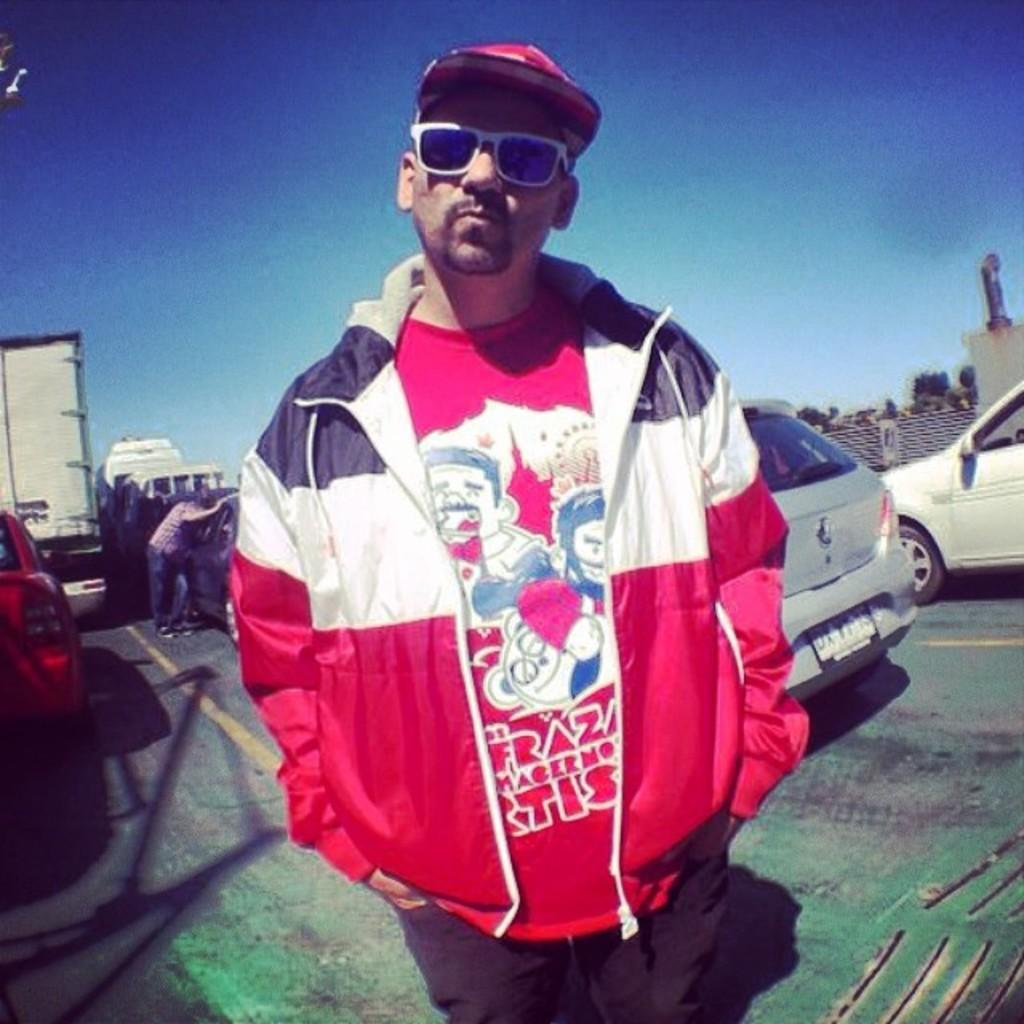What is the main subject of the image? There is a man standing in the image. Can you describe the man's appearance? The man is wearing spectacles and a cap. What can be seen in the background of the image? There are vehicles moving on the road and buildings visible in the background of the image. What type of door can be seen in the image? There is no door present in the image; it features a man standing and a background with vehicles and buildings. Can you tell me how many zebras are visible in the image? There are no zebras present in the image. 